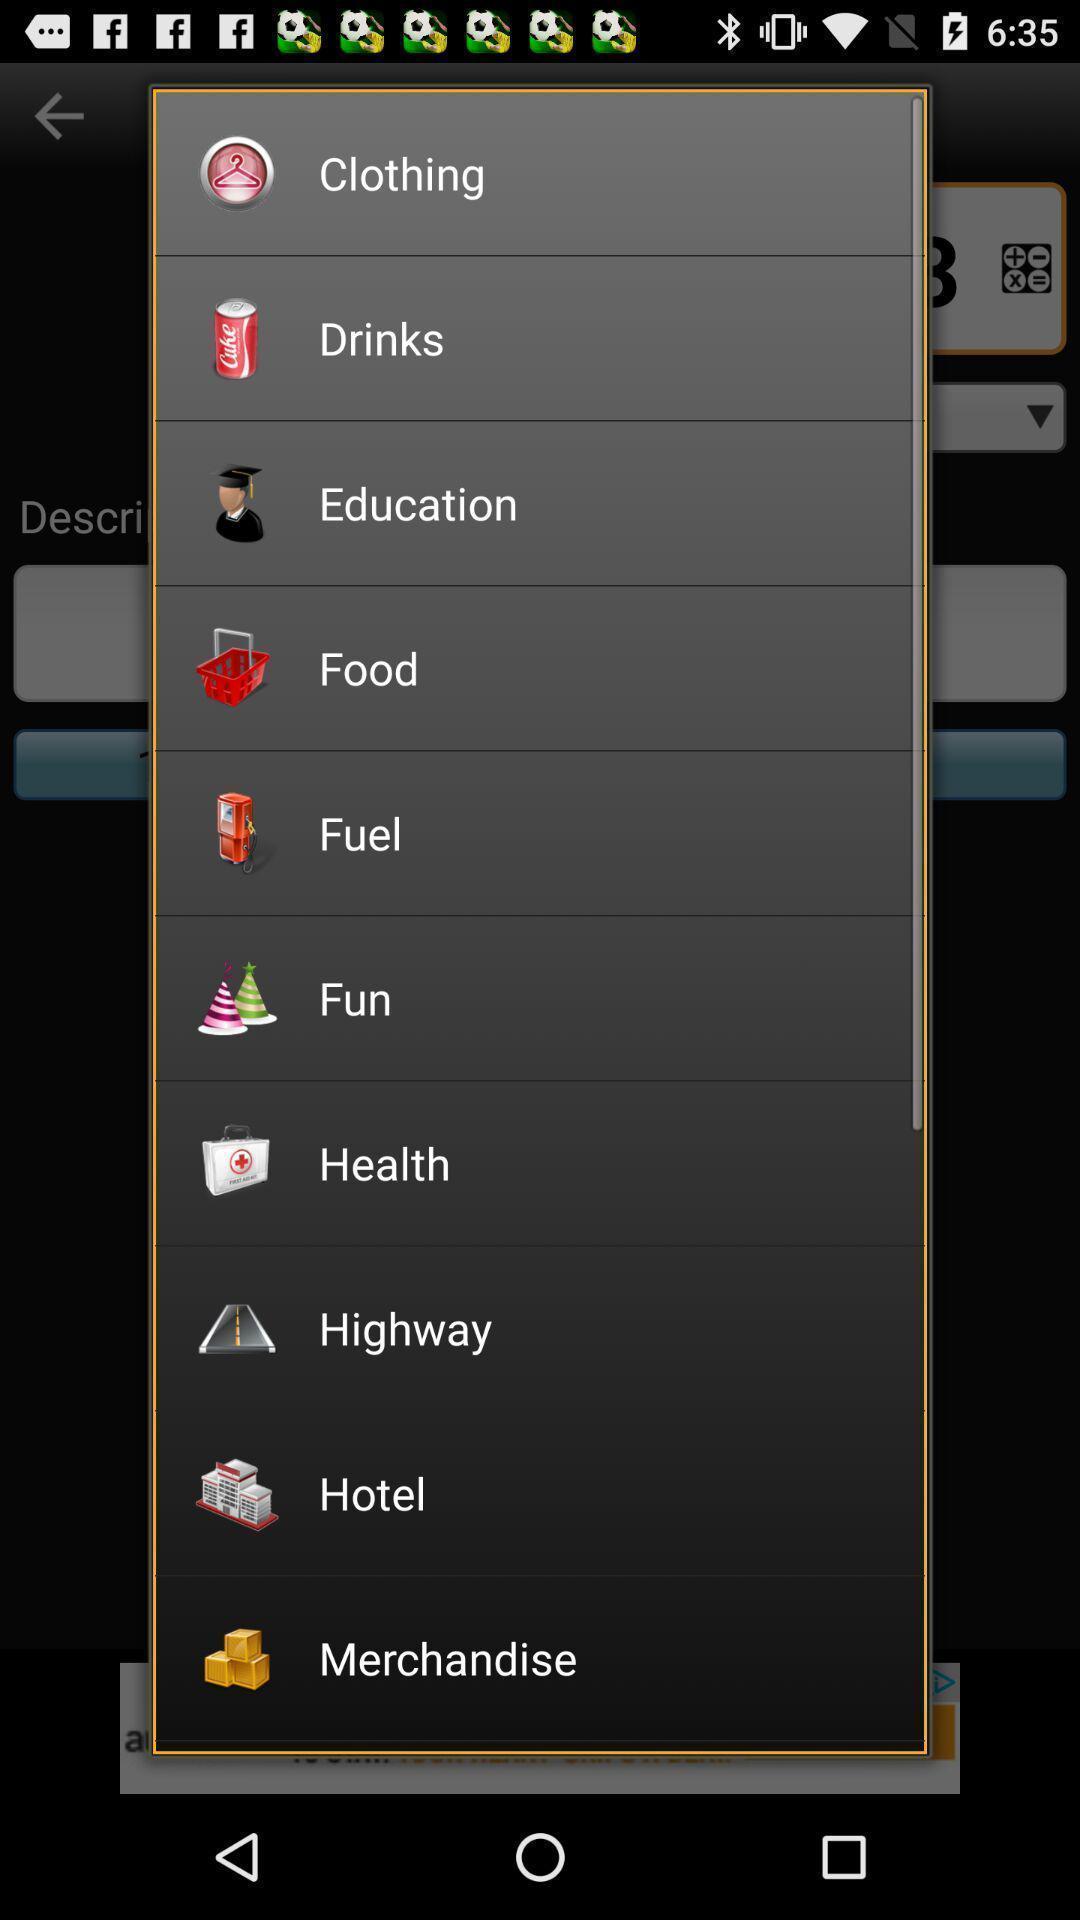Provide a detailed account of this screenshot. Pop-up displaying with list of different categories. 